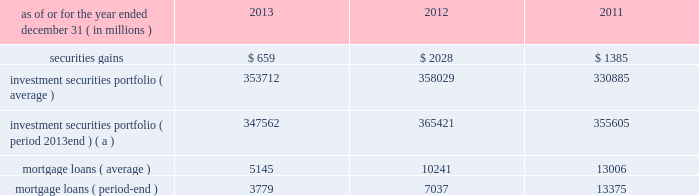Management 2019s discussion and analysis 110 jpmorgan chase & co./2013 annual report 2012 compared with 2011 net loss was $ 2.0 billion , compared with a net income of $ 919 million in the prior year .
Private equity reported net income of $ 292 million , compared with net income of $ 391 million in the prior year .
Net revenue was $ 601 million , compared with $ 836 million in the prior year , due to lower unrealized and realized gains on private investments , partially offset by higher unrealized gains on public securities .
Noninterest expense was $ 145 million , down from $ 238 million in the prior year .
Treasury and cio reported a net loss of $ 2.1 billion , compared with net income of $ 1.3 billion in the prior year .
Net revenue was a loss of $ 3.1 billion , compared with net revenue of $ 3.2 billion in the prior year .
The current year loss reflected $ 5.8 billion of losses incurred by cio from the synthetic credit portfolio for the six months ended june 30 , 2012 , and $ 449 million of losses from the retained index credit derivative positions for the three months ended september 30 , 2012 .
These losses were partially offset by securities gains of $ 2.0 billion .
The current year revenue reflected $ 888 million of extinguishment gains related to the redemption of trust preferred securities , which are included in all other income in the above table .
The extinguishment gains were related to adjustments applied to the cost basis of the trust preferred securities during the period they were in a qualified hedge accounting relationship .
Net interest income was negative $ 683 million , compared with $ 1.4 billion in the prior year , primarily reflecting the impact of lower portfolio yields and higher deposit balances across the firm .
Other corporate reported a net loss of $ 221 million , compared with a net loss of $ 821 million in the prior year .
Noninterest revenue of $ 1.8 billion was driven by a $ 1.1 billion benefit for the washington mutual bankruptcy settlement , which is included in all other income in the above table , and a $ 665 million gain from the recovery on a bear stearns-related subordinated loan .
Noninterest expense of $ 3.8 billion was up $ 1.0 billion compared with the prior year .
The current year included expense of $ 3.7 billion for additional litigation reserves , largely for mortgage-related matters .
The prior year included expense of $ 3.2 billion for additional litigation reserves .
Treasury and cio overview treasury and cio are predominantly responsible for measuring , monitoring , reporting and managing the firm 2019s liquidity , funding and structural interest rate and foreign exchange risks , as well as executing the firm 2019s capital plan .
The risks managed by treasury and cio arise from the activities undertaken by the firm 2019s four major reportable business segments to serve their respective client bases , which generate both on- and off-balance sheet assets and liabilities .
Cio achieves the firm 2019s asset-liability management objectives generally by investing in high-quality securities that are managed for the longer-term as part of the firm 2019s afs and htm investment securities portfolios ( the 201cinvestment securities portfolio 201d ) .
Cio also uses derivatives , as well as securities that are not classified as afs or htm , to meet the firm 2019s asset-liability management objectives .
For further information on derivatives , see note 6 on pages 220 2013233 of this annual report .
For further information about securities not classified within the afs or htm portfolio , see note 3 on pages 195 2013215 of this annual report .
The treasury and cio investment securities portfolio primarily consists of u.s .
And non-u.s .
Government securities , agency and non-agency mortgage-backed securities , other asset-backed securities , corporate debt securities and obligations of u.s .
States and municipalities .
At december 31 , 2013 , the total treasury and cio investment securities portfolio was $ 347.6 billion ; the average credit rating of the securities comprising the treasury and cio investment securities portfolio was aa+ ( based upon external ratings where available and where not available , based primarily upon internal ratings that correspond to ratings as defined by s&p and moody 2019s ) .
See note 12 on pages 249 2013254 of this annual report for further information on the details of the firm 2019s investment securities portfolio .
For further information on liquidity and funding risk , see liquidity risk management on pages 168 2013173 of this annual report .
For information on interest rate , foreign exchange and other risks , treasury and cio value-at-risk ( 201cvar 201d ) and the firm 2019s structural interest rate-sensitive revenue at risk , see market risk management on pages 142 2013148 of this annual report .
Selected income statement and balance sheet data as of or for the year ended december 31 , ( in millions ) 2013 2012 2011 .
( a ) period-end investment securities included held-to-maturity balance of $ 24.0 billion at december 31 , 2013 .
Held-to-maturity balances for the other periods were not material. .
Based on the management 2019s discussion and analysis 110 jpmorgan chase & co what was the change in net income from 2011 to 2012 in billions? 
Computations: ((2.0 * const_m1) - 919)
Answer: -921.0. 